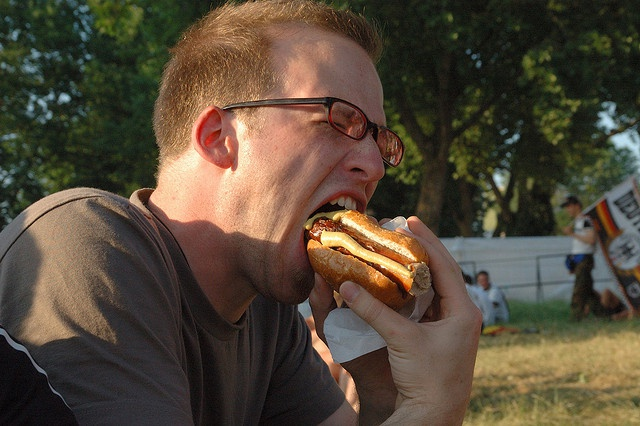Describe the objects in this image and their specific colors. I can see people in darkgreen, black, gray, and maroon tones, hot dog in darkgreen, maroon, brown, orange, and khaki tones, people in darkgreen, black, gray, and maroon tones, people in darkgreen, gray, black, purple, and maroon tones, and people in darkgreen, gray, and black tones in this image. 